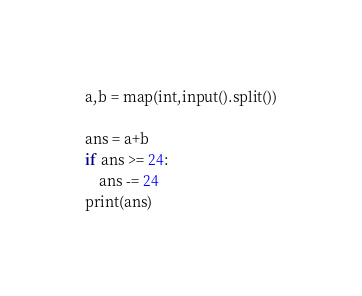Convert code to text. <code><loc_0><loc_0><loc_500><loc_500><_Python_>a,b = map(int,input().split())

ans = a+b
if ans >= 24:
    ans -= 24
print(ans)</code> 